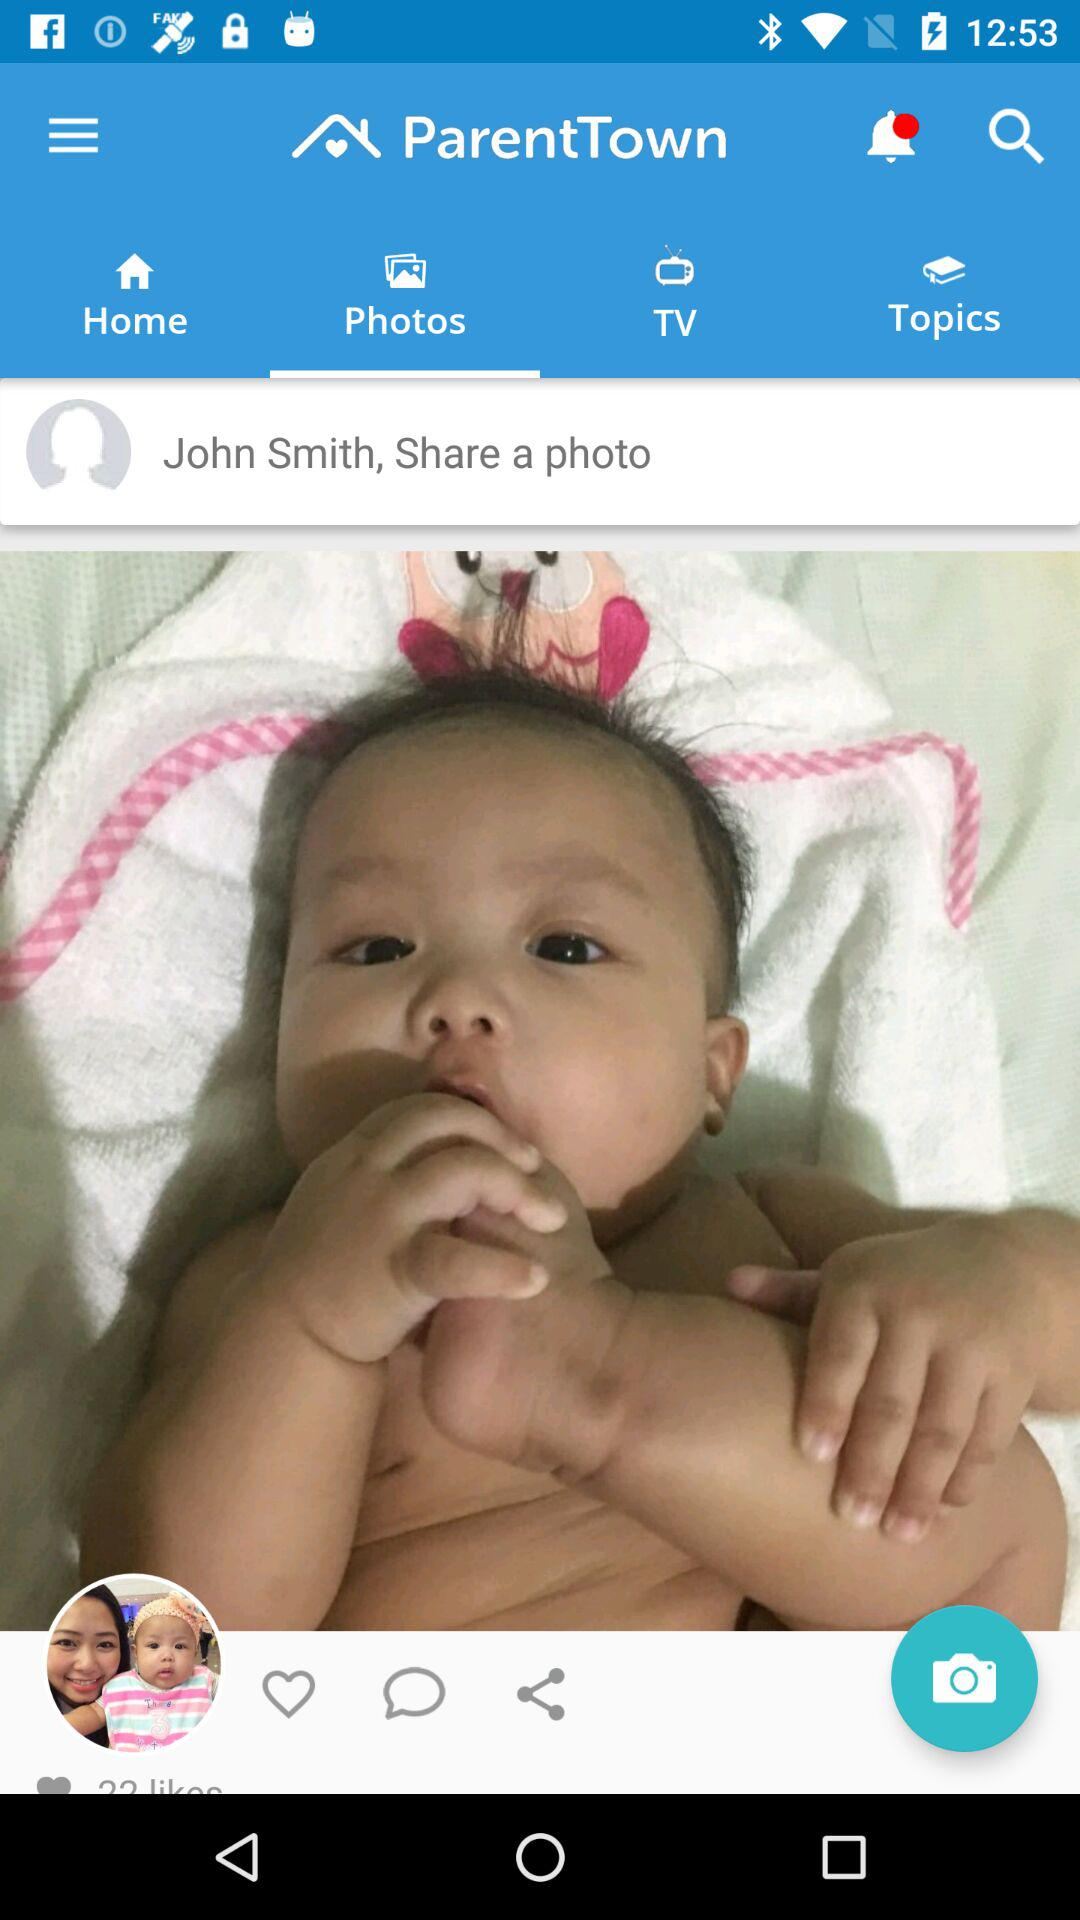What is the name of the application? The application name is "ParentTown". 